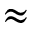Convert formula to latex. <formula><loc_0><loc_0><loc_500><loc_500>\approx</formula> 